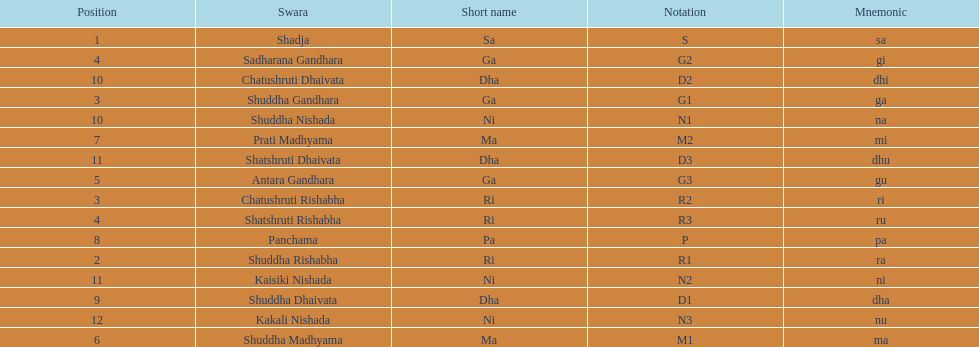Other than m1 how many notations have "1" in them? 4. 